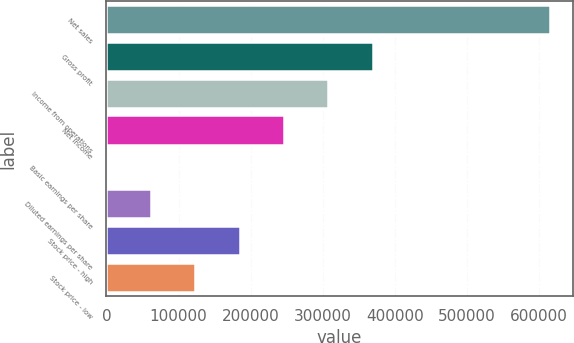Convert chart to OTSL. <chart><loc_0><loc_0><loc_500><loc_500><bar_chart><fcel>Net sales<fcel>Gross profit<fcel>Income from operations<fcel>Net income<fcel>Basic earnings per share<fcel>Diluted earnings per share<fcel>Stock price - high<fcel>Stock price - low<nl><fcel>615459<fcel>369276<fcel>307730<fcel>246184<fcel>0.37<fcel>61546.2<fcel>184638<fcel>123092<nl></chart> 